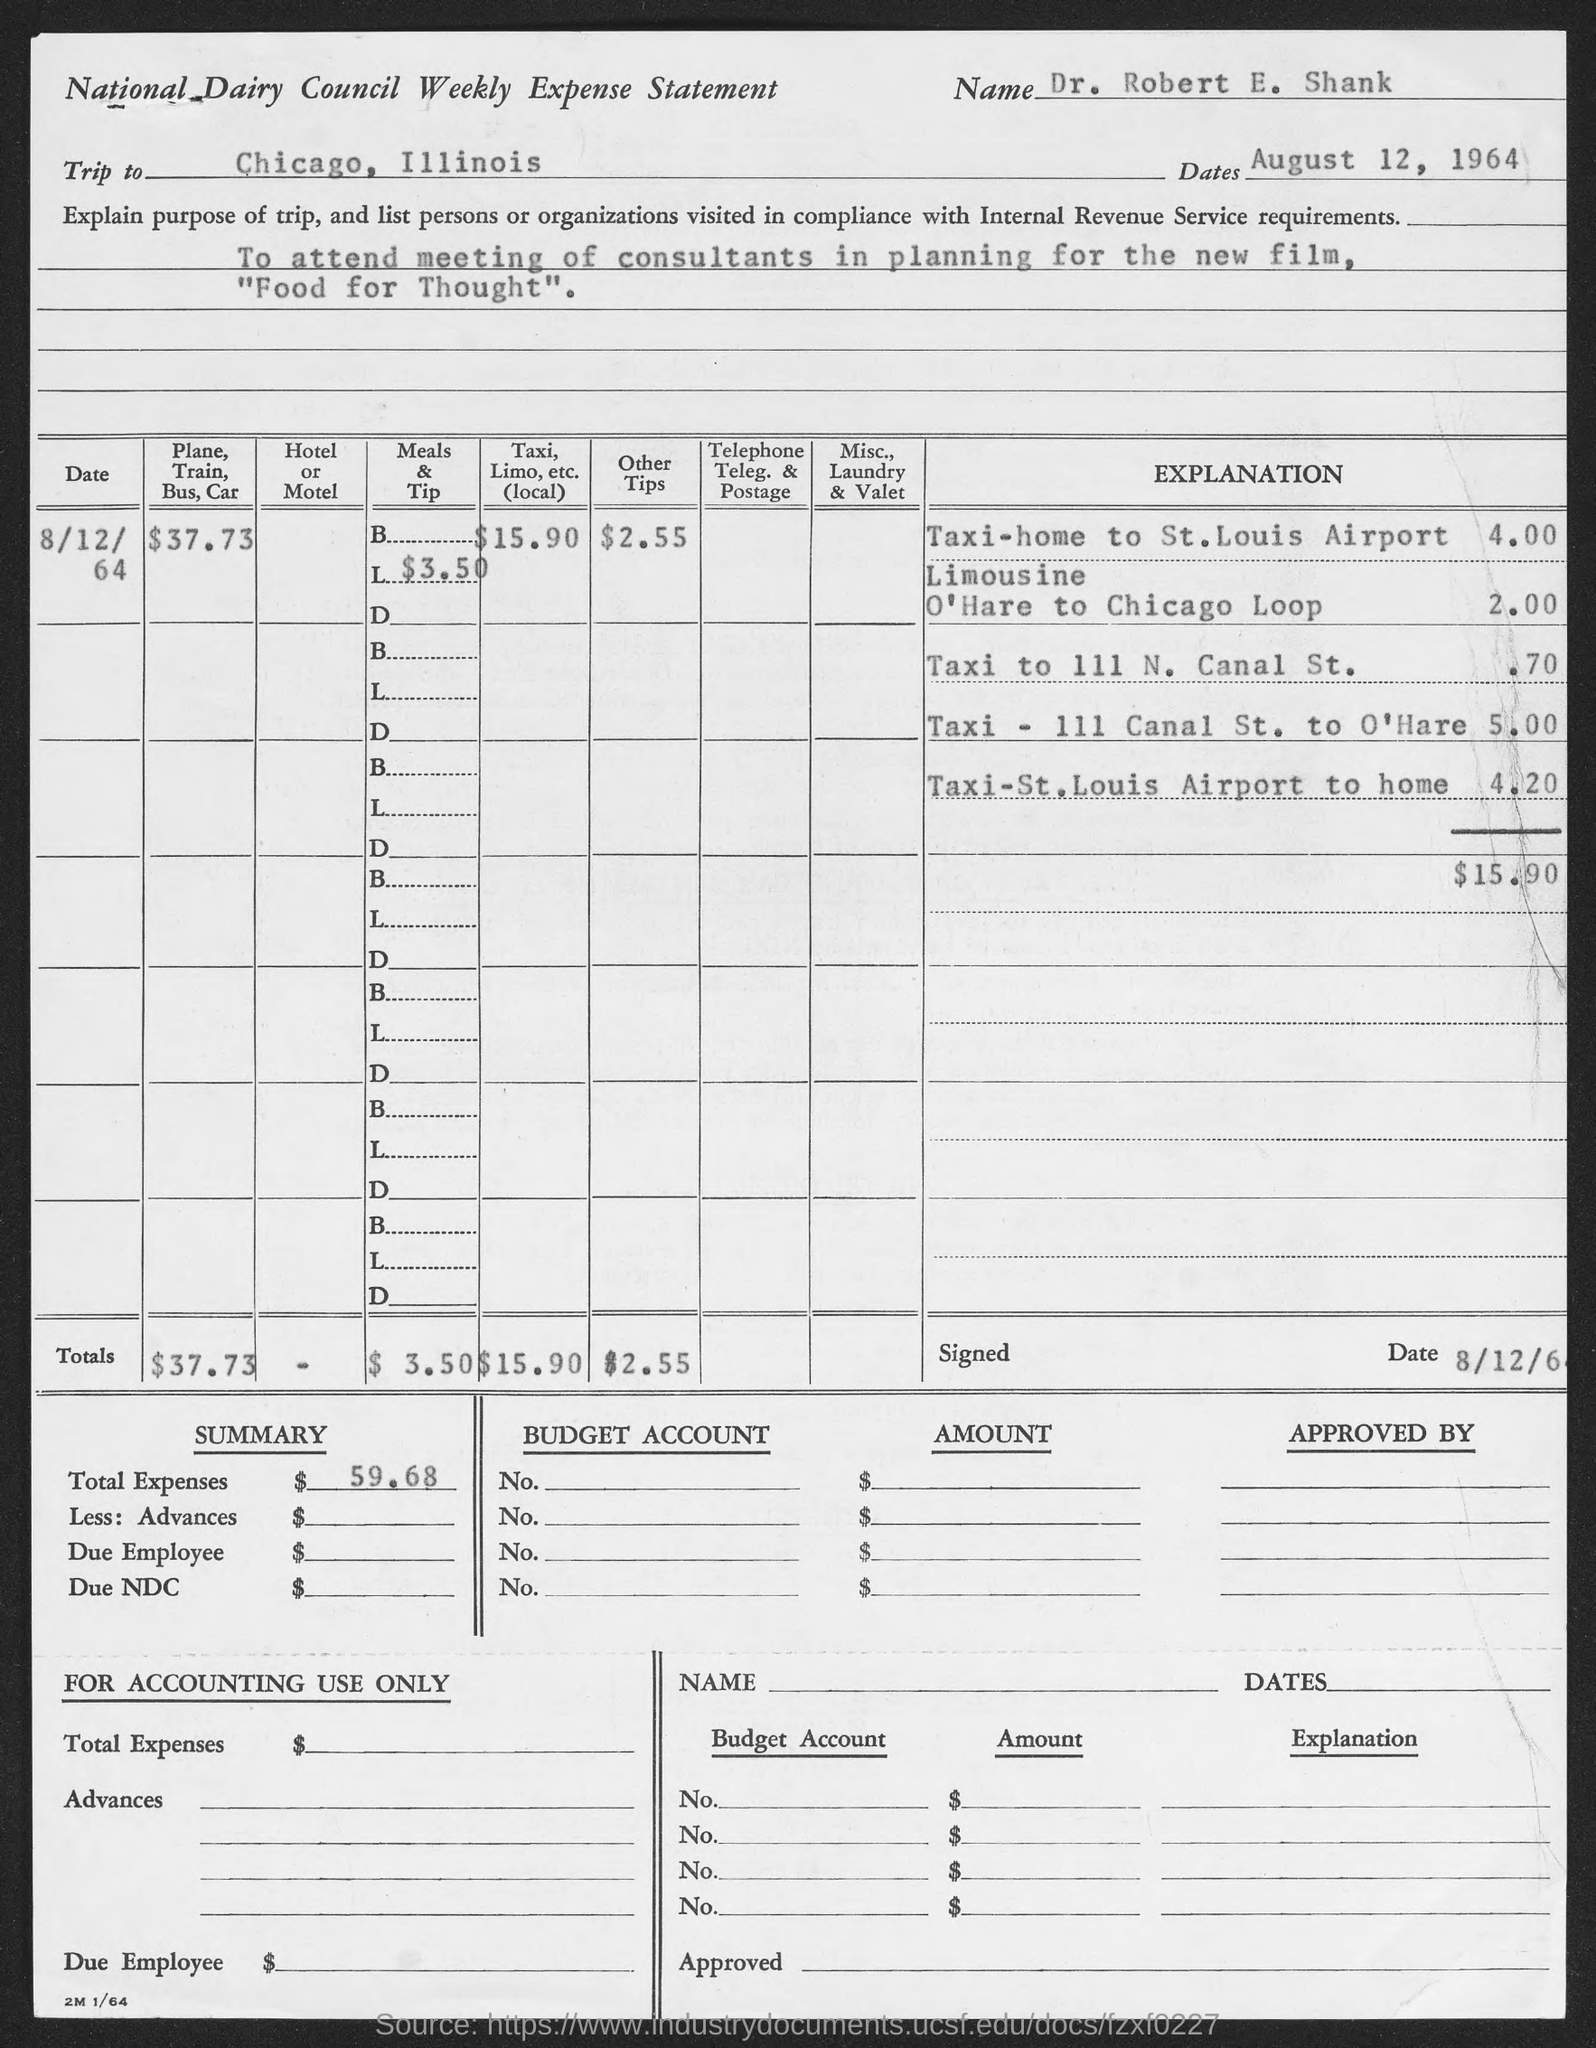What is the form about?
Make the answer very short. National Dairy Council Weekly Expense Statement. What is the name given?
Offer a very short reply. Dr. Robert E. Shank. Where is the trip to?
Provide a succinct answer. Chicago, Illinois. What is the date given?
Your answer should be compact. August 12, 1964. What is the name of the new film?
Provide a succinct answer. "Food for Thought". How much is "Other Tips"?
Provide a short and direct response. 2.55. What is the Total expense?
Keep it short and to the point. $59.68. 